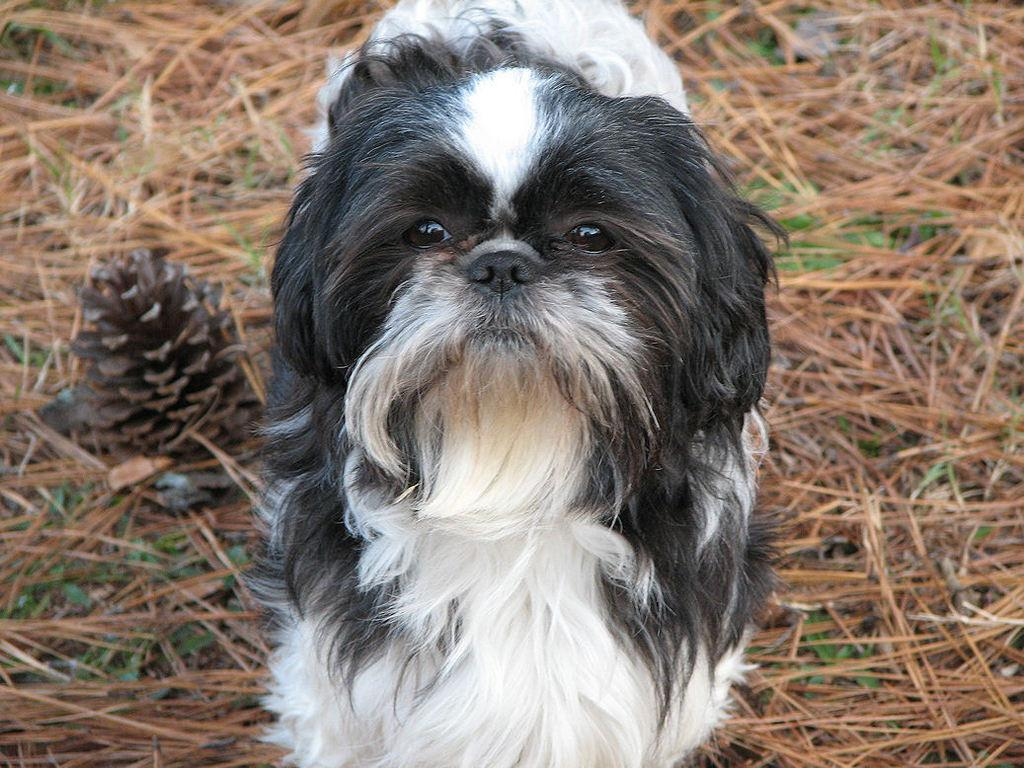How many dogs are in the image? There are two dogs in the image, one white and one black. What is the ground made of in the image? The ground has grass on it. Can you describe any other objects in the image? There is a pine cone in the image. What channel is the dogs watching in the image? There is no television or channel present in the image; it features two dogs and a pine cone on grass. 